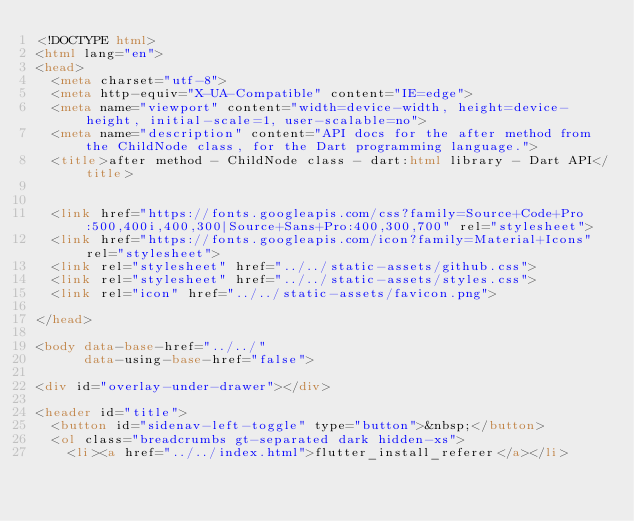<code> <loc_0><loc_0><loc_500><loc_500><_HTML_><!DOCTYPE html>
<html lang="en">
<head>
  <meta charset="utf-8">
  <meta http-equiv="X-UA-Compatible" content="IE=edge">
  <meta name="viewport" content="width=device-width, height=device-height, initial-scale=1, user-scalable=no">
  <meta name="description" content="API docs for the after method from the ChildNode class, for the Dart programming language.">
  <title>after method - ChildNode class - dart:html library - Dart API</title>

  
  <link href="https://fonts.googleapis.com/css?family=Source+Code+Pro:500,400i,400,300|Source+Sans+Pro:400,300,700" rel="stylesheet">
  <link href="https://fonts.googleapis.com/icon?family=Material+Icons" rel="stylesheet">
  <link rel="stylesheet" href="../../static-assets/github.css">
  <link rel="stylesheet" href="../../static-assets/styles.css">
  <link rel="icon" href="../../static-assets/favicon.png">

</head>

<body data-base-href="../../"
      data-using-base-href="false">

<div id="overlay-under-drawer"></div>

<header id="title">
  <button id="sidenav-left-toggle" type="button">&nbsp;</button>
  <ol class="breadcrumbs gt-separated dark hidden-xs">
    <li><a href="../../index.html">flutter_install_referer</a></li></code> 